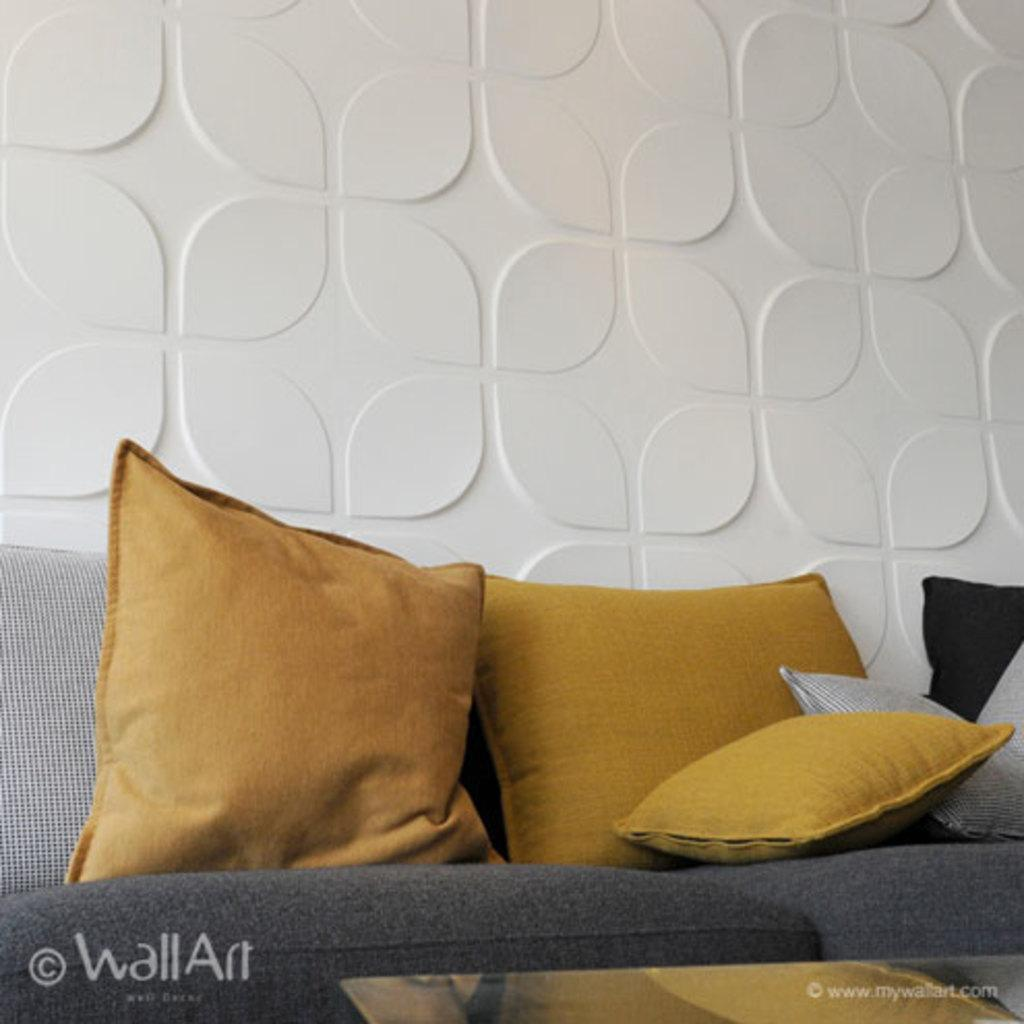What is the color and design of the wall in the image? The wall is white in color and has a unique design. What type of seating is present in the image? There is a sofa with cushions in the image. What kind of table can be seen in the image? There is a glass table in the image. How many heads can be seen on the sofa in the image? There are no heads visible on the sofa in the image. 